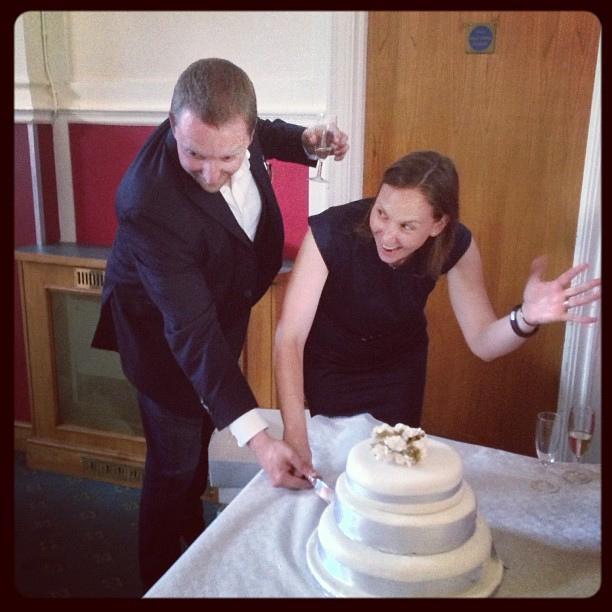How many people are holding a wine glass?
Give a very brief answer. 1. How many people are in the photo?
Give a very brief answer. 2. How many yellow umbrellas are there?
Give a very brief answer. 0. 